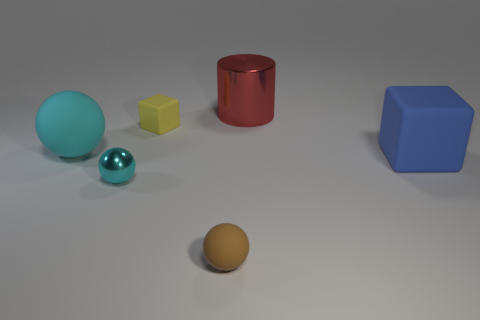Imagine these objects are part of a game, could you invent a point system for them? Absolutely, let’s create a simple point system for a game using these objects. Each yellow object could be worth 5 points, the red cylinder 10 points, the large blue cube 15 points, and the glossy items could be 'bonus' items with the small turquoise sphere worth 20 points and the larger cyan sphere worth 25 points. Let’s say the objective is to 'collect' these objects by touching them within a virtual world to accumulate points. An exciting twist would be that some objects might grant special abilities or trigger events within this imaginary game! 